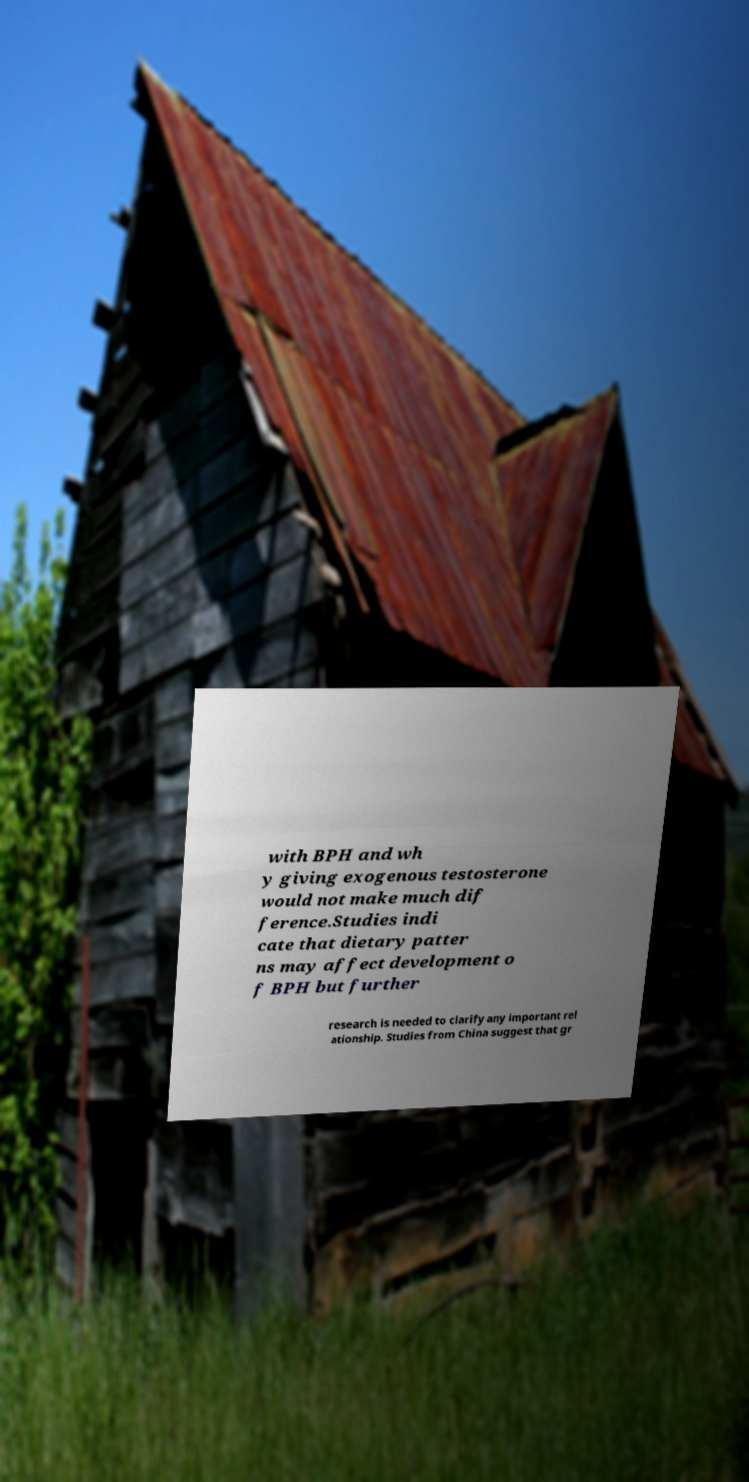Please read and relay the text visible in this image. What does it say? with BPH and wh y giving exogenous testosterone would not make much dif ference.Studies indi cate that dietary patter ns may affect development o f BPH but further research is needed to clarify any important rel ationship. Studies from China suggest that gr 